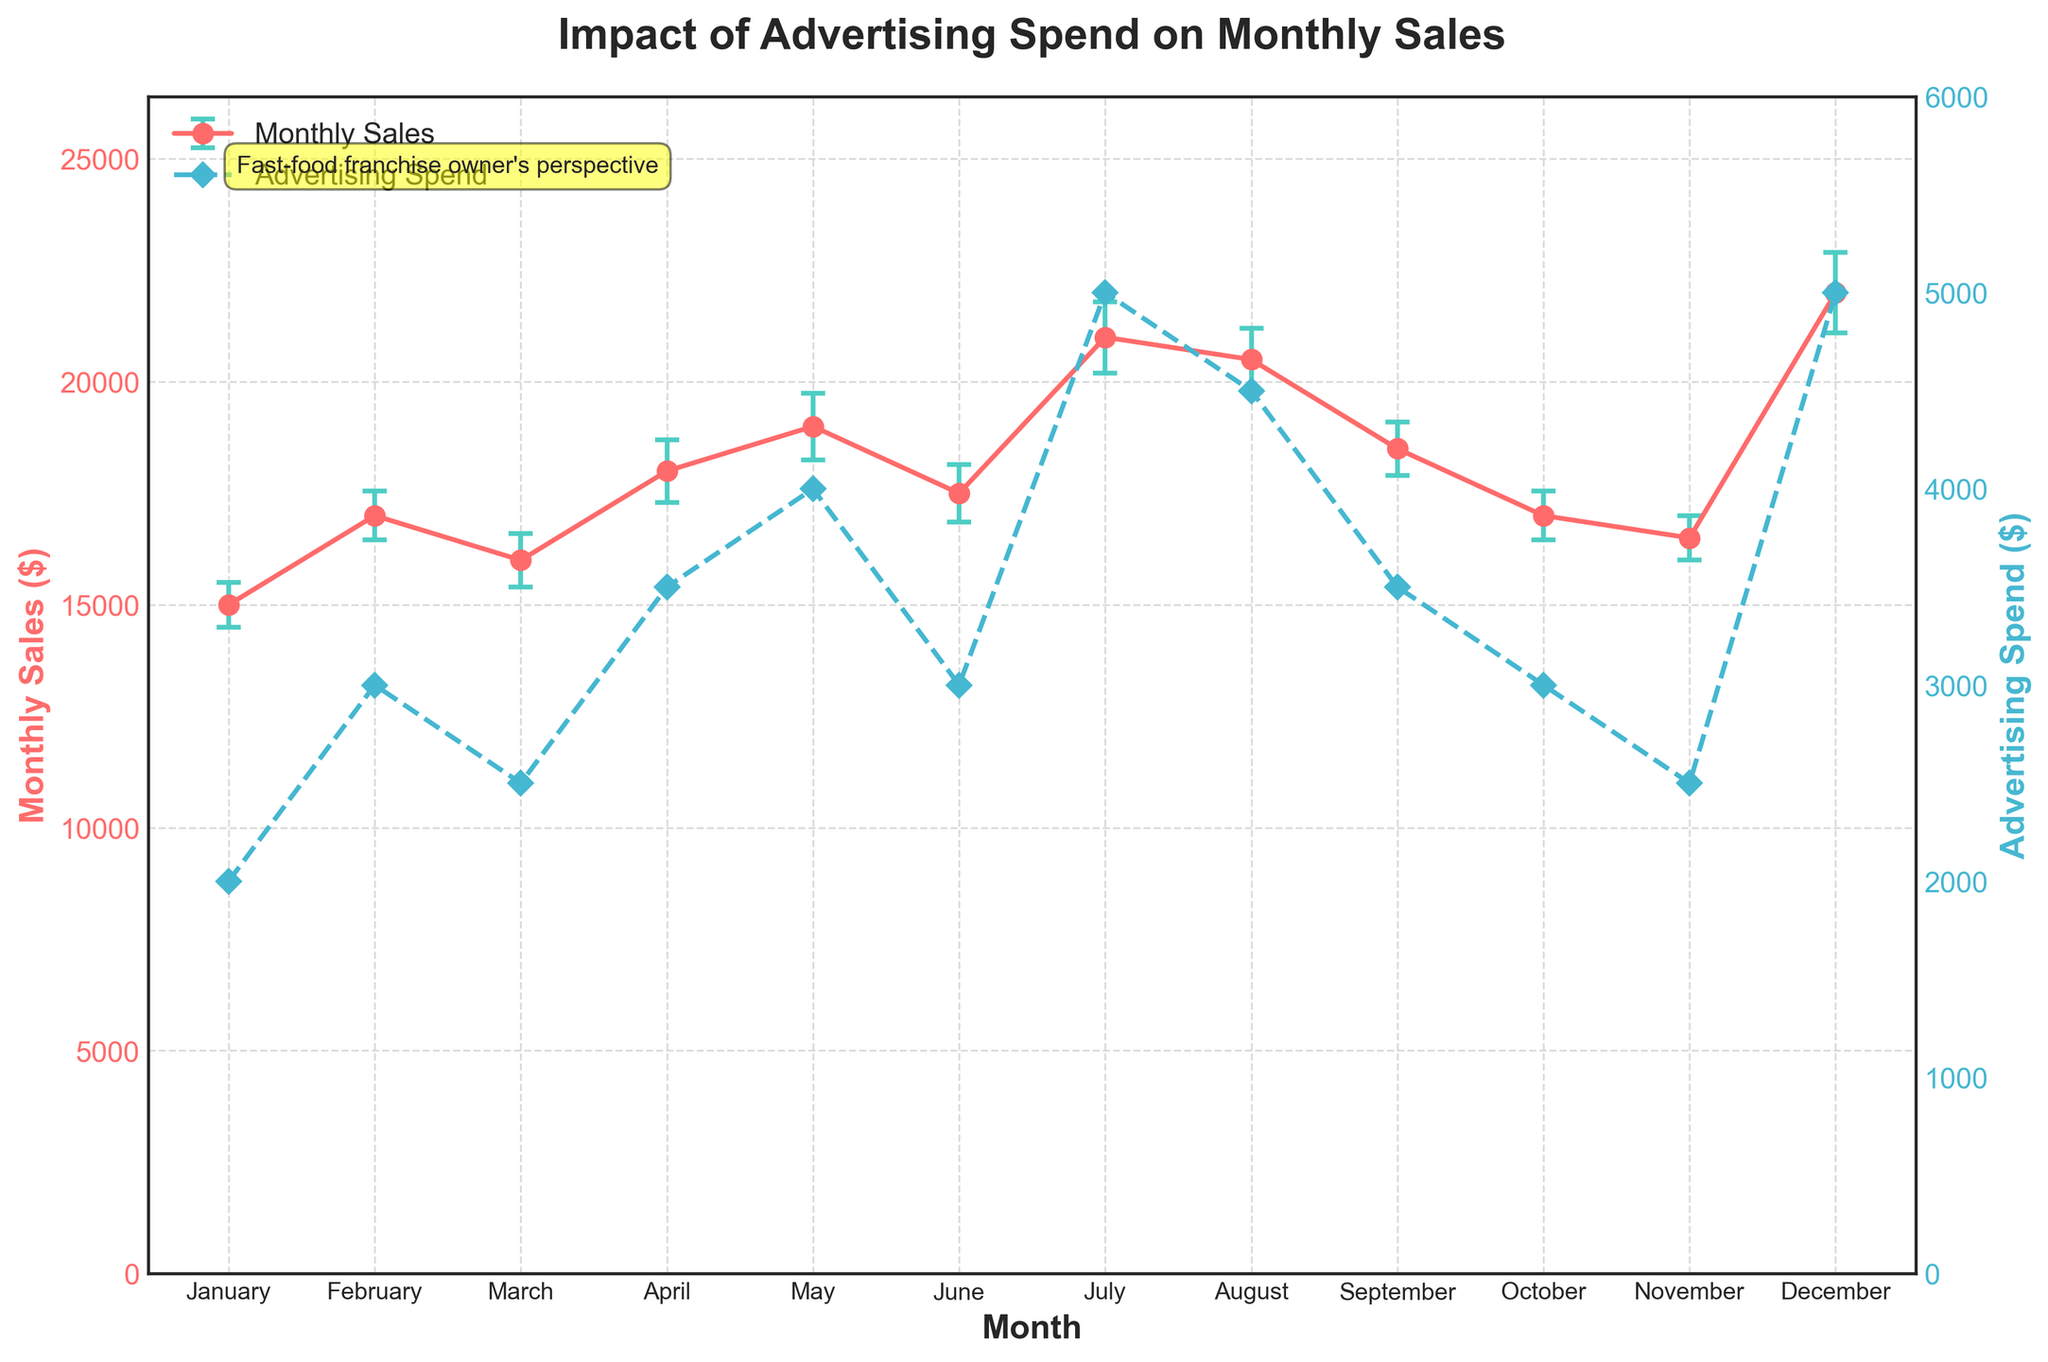what is the title of the figure? The title of the figure is positioned at the top and states the purpose of the analysis.
Answer: Impact of Advertising Spend on Monthly Sales how many months shows an advertising spend of $3000? Referring to the secondary y-axis, February, June, and October each show an advertising spend of $3000.
Answer: 3 what is the monthly sales amount in August? The data point for August on the primary y-axis shows that the monthly sales are represented by a point indicating $20500.
Answer: 20500 which month recorded the highest monthly sales and what were the sales? By examining the highest point on the primary y-axis, December shows the highest monthly sales.
Answer: December, 22000 how do the monthly sales in February compare with those in November? Comparing the data points for February and November on the primary y-axis, February has higher sales ($17000) compared to November ($16500).
Answer: February > November what is the standard error of monthly sales in April? The error bar for April reflects a sales error of $700 as stated in the data.
Answer: 700 how much more were the monthly sales in July compared to March? Subtract the sales value of March from July's: $21000 - $16000 = $5000.
Answer: 5000 which month had the highest advertising spend and what was the spend amount? Observing the secondary y-axis plot, July and December had the highest advertising spend of $5000.
Answer: July, December, 5000 what trend can be observed between advertising spend and monthly sales? A general increasing trend can be seen, where higher advertising spend often coincides with higher monthly sales, although there are some exceptions.
Answer: Higher spend, higher sales for which month is the sales error smallest, and what is the approximate value? The shortest error bar is observed in January, indicating the smallest sales error of approximately $500.
Answer: January, 500 